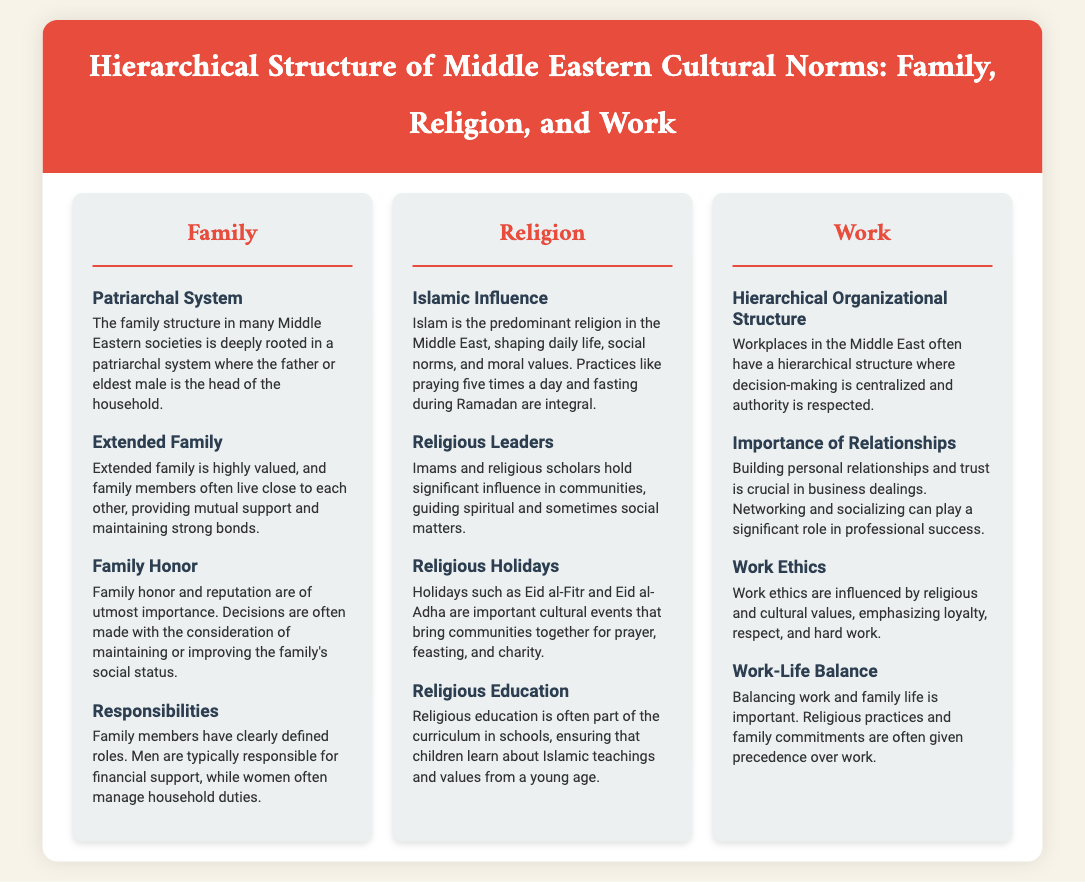What is the primary family structure in the Middle East? The document states that the family structure in many Middle Eastern societies is deeply rooted in a patriarchal system.
Answer: Patriarchal system What does family honor entail in Middle Eastern cultures? According to the document, family honor and reputation are considered of utmost importance, influencing decisions regarding social status.
Answer: Family honor What is the predominant religion in the Middle East? The document mentions that Islam is the predominant religion affecting daily life and social norms.
Answer: Islam What are two key religious holidays mentioned? The text refers to Eid al-Fitr and Eid al-Adha as important cultural events that involve community gatherings.
Answer: Eid al-Fitr and Eid al-Adha How do workplaces typically function in terms of hierarchy? The document explains that workplaces in the Middle East often have a hierarchical structure with centralized decision-making.
Answer: Hierarchical structure What role do personal relationships play in business? The section on work indicates that building personal relationships and trust is crucial in business dealings.
Answer: Personal relationships What is emphasized in work ethics within the region? The document highlights that work ethics in the Middle East are influenced by religious and cultural values, emphasizing loyalty, respect, and hard work.
Answer: Loyalty, respect, and hard work What is said about work-life balance? According to the document, balancing work and family life is important, with religious practices often given precedence over work.
Answer: Work-life balance 